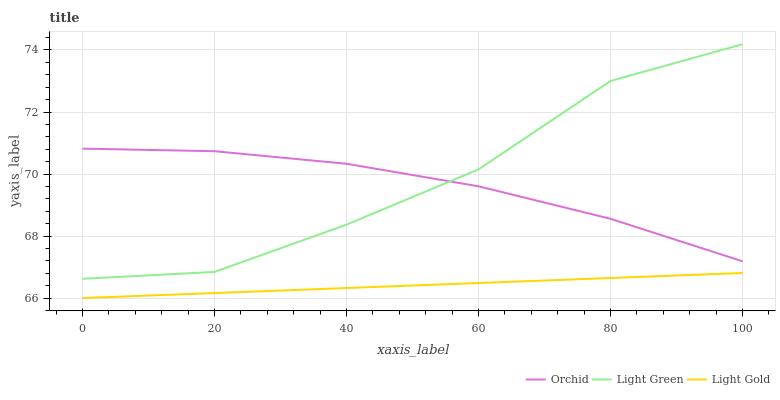Does Light Gold have the minimum area under the curve?
Answer yes or no. Yes. Does Light Green have the maximum area under the curve?
Answer yes or no. Yes. Does Orchid have the minimum area under the curve?
Answer yes or no. No. Does Orchid have the maximum area under the curve?
Answer yes or no. No. Is Light Gold the smoothest?
Answer yes or no. Yes. Is Light Green the roughest?
Answer yes or no. Yes. Is Orchid the smoothest?
Answer yes or no. No. Is Orchid the roughest?
Answer yes or no. No. Does Light Gold have the lowest value?
Answer yes or no. Yes. Does Light Green have the lowest value?
Answer yes or no. No. Does Light Green have the highest value?
Answer yes or no. Yes. Does Orchid have the highest value?
Answer yes or no. No. Is Light Gold less than Orchid?
Answer yes or no. Yes. Is Light Green greater than Light Gold?
Answer yes or no. Yes. Does Light Green intersect Orchid?
Answer yes or no. Yes. Is Light Green less than Orchid?
Answer yes or no. No. Is Light Green greater than Orchid?
Answer yes or no. No. Does Light Gold intersect Orchid?
Answer yes or no. No. 